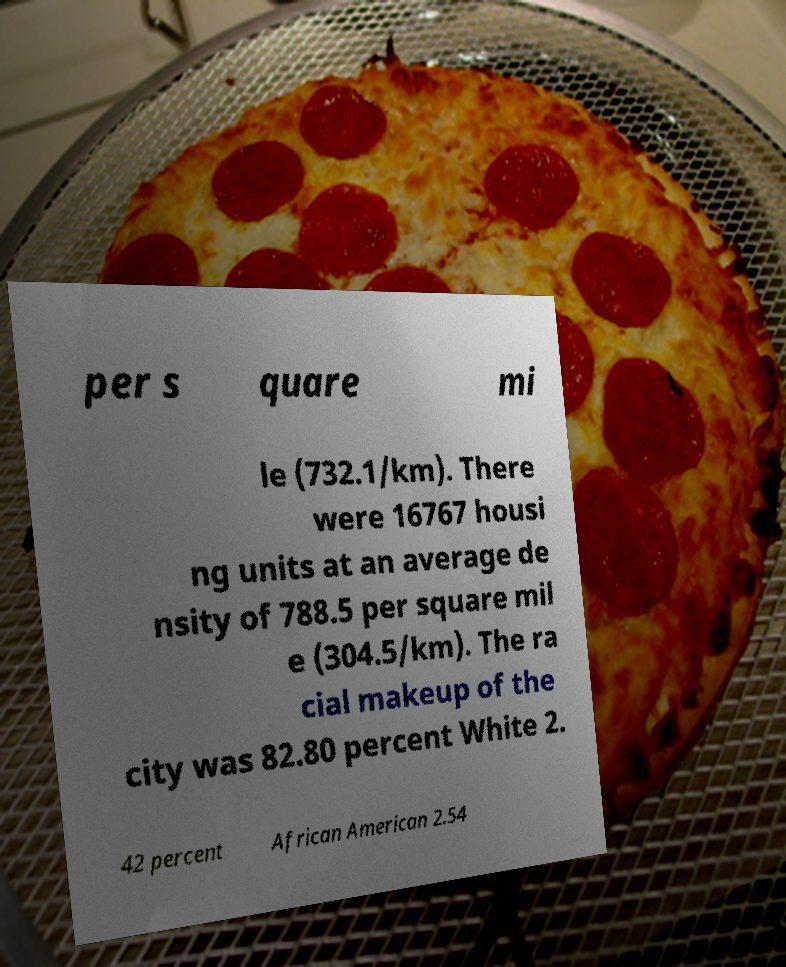Could you assist in decoding the text presented in this image and type it out clearly? per s quare mi le (732.1/km). There were 16767 housi ng units at an average de nsity of 788.5 per square mil e (304.5/km). The ra cial makeup of the city was 82.80 percent White 2. 42 percent African American 2.54 